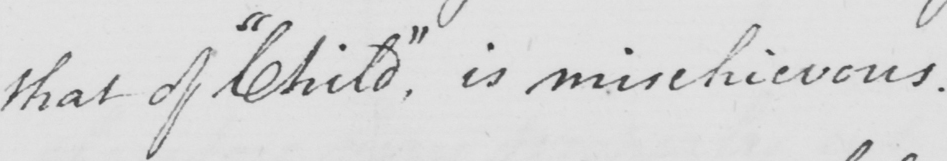What is written in this line of handwriting? that of  " Child "  is mischievous . 